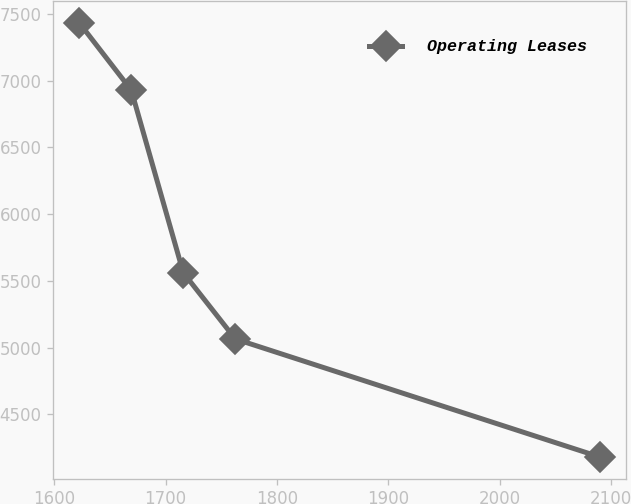<chart> <loc_0><loc_0><loc_500><loc_500><line_chart><ecel><fcel>Operating Leases<nl><fcel>1622.42<fcel>7433.84<nl><fcel>1669.14<fcel>6929.26<nl><fcel>1715.86<fcel>5560.86<nl><fcel>1762.58<fcel>5064.16<nl><fcel>2089.66<fcel>4179.97<nl></chart> 